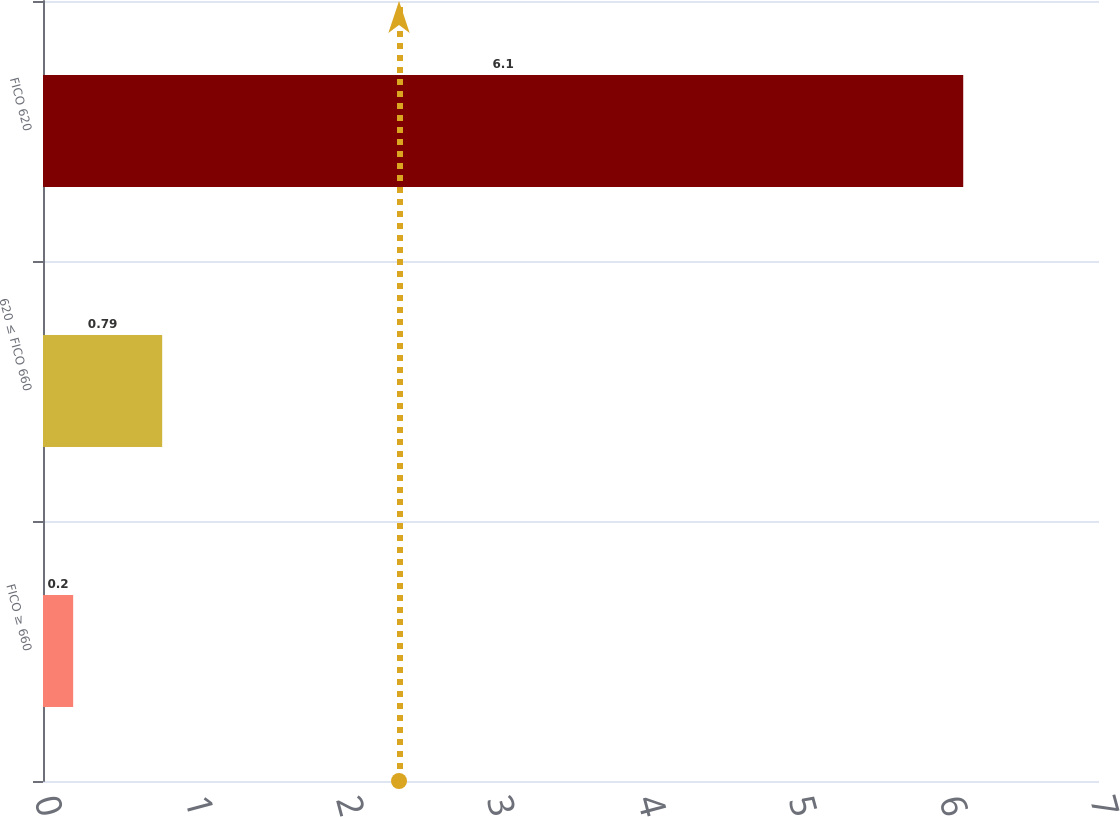<chart> <loc_0><loc_0><loc_500><loc_500><bar_chart><fcel>FICO ≥ 660<fcel>620 ≤ FICO 660<fcel>FICO 620<nl><fcel>0.2<fcel>0.79<fcel>6.1<nl></chart> 